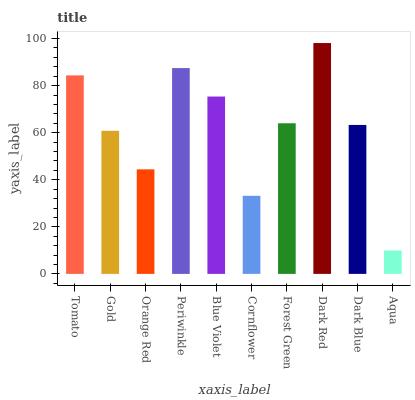Is Aqua the minimum?
Answer yes or no. Yes. Is Dark Red the maximum?
Answer yes or no. Yes. Is Gold the minimum?
Answer yes or no. No. Is Gold the maximum?
Answer yes or no. No. Is Tomato greater than Gold?
Answer yes or no. Yes. Is Gold less than Tomato?
Answer yes or no. Yes. Is Gold greater than Tomato?
Answer yes or no. No. Is Tomato less than Gold?
Answer yes or no. No. Is Forest Green the high median?
Answer yes or no. Yes. Is Dark Blue the low median?
Answer yes or no. Yes. Is Gold the high median?
Answer yes or no. No. Is Aqua the low median?
Answer yes or no. No. 